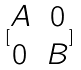<formula> <loc_0><loc_0><loc_500><loc_500>[ \begin{matrix} A & 0 \\ 0 & B \end{matrix} ]</formula> 